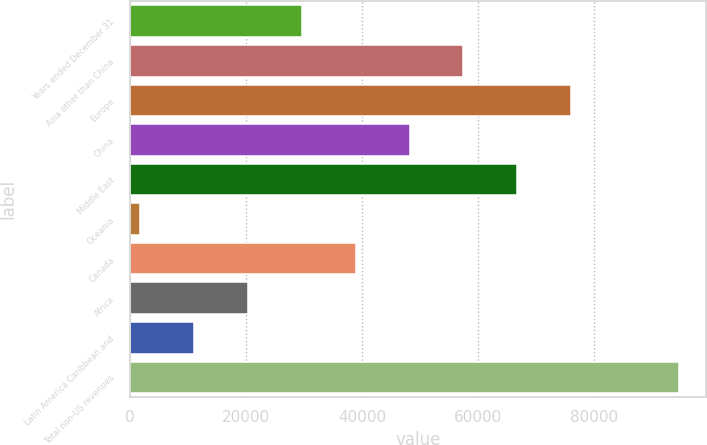<chart> <loc_0><loc_0><loc_500><loc_500><bar_chart><fcel>Years ended December 31<fcel>Asia other than China<fcel>Europe<fcel>China<fcel>Middle East<fcel>Oceania<fcel>Canada<fcel>Africa<fcel>Latin America Caribbean and<fcel>Total non-US revenues<nl><fcel>29661.4<fcel>57479.8<fcel>76025.4<fcel>48207<fcel>66752.6<fcel>1843<fcel>38934.2<fcel>20388.6<fcel>11115.8<fcel>94571<nl></chart> 